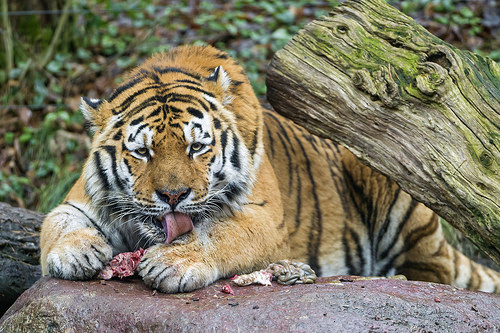<image>
Can you confirm if the tiger is on the log? No. The tiger is not positioned on the log. They may be near each other, but the tiger is not supported by or resting on top of the log. Where is the lion in relation to the tree? Is it under the tree? Yes. The lion is positioned underneath the tree, with the tree above it in the vertical space. Is there a log next to the tiger? Yes. The log is positioned adjacent to the tiger, located nearby in the same general area. 